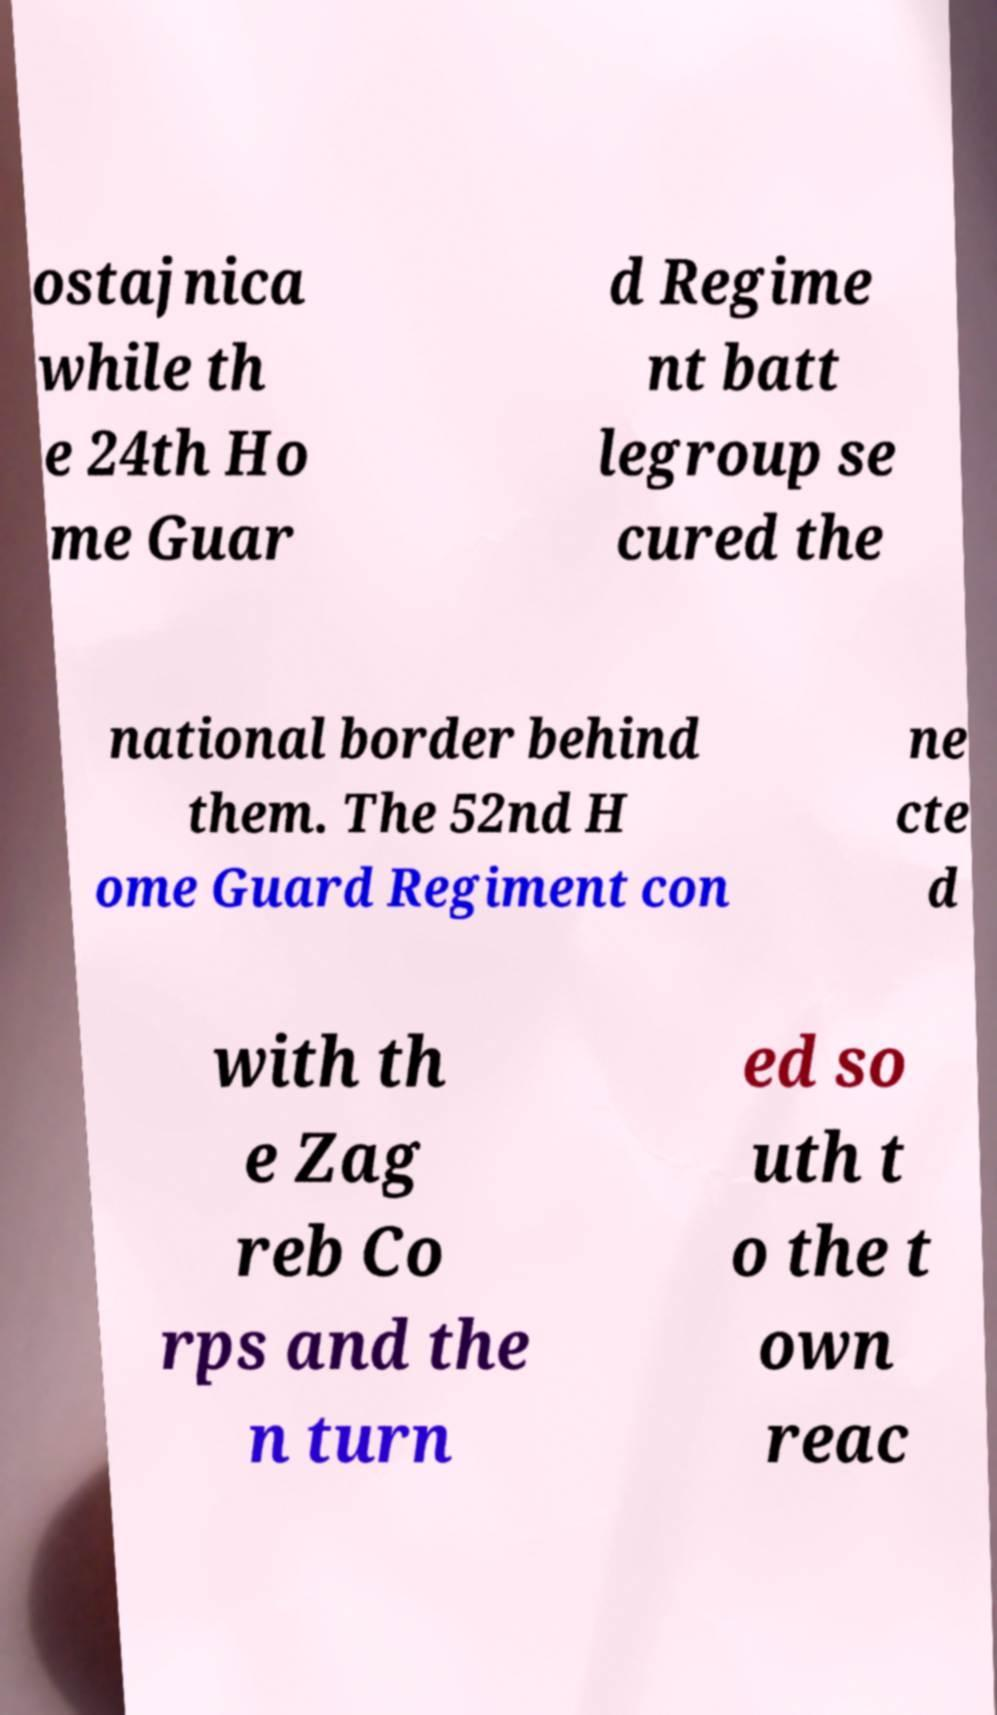For documentation purposes, I need the text within this image transcribed. Could you provide that? ostajnica while th e 24th Ho me Guar d Regime nt batt legroup se cured the national border behind them. The 52nd H ome Guard Regiment con ne cte d with th e Zag reb Co rps and the n turn ed so uth t o the t own reac 